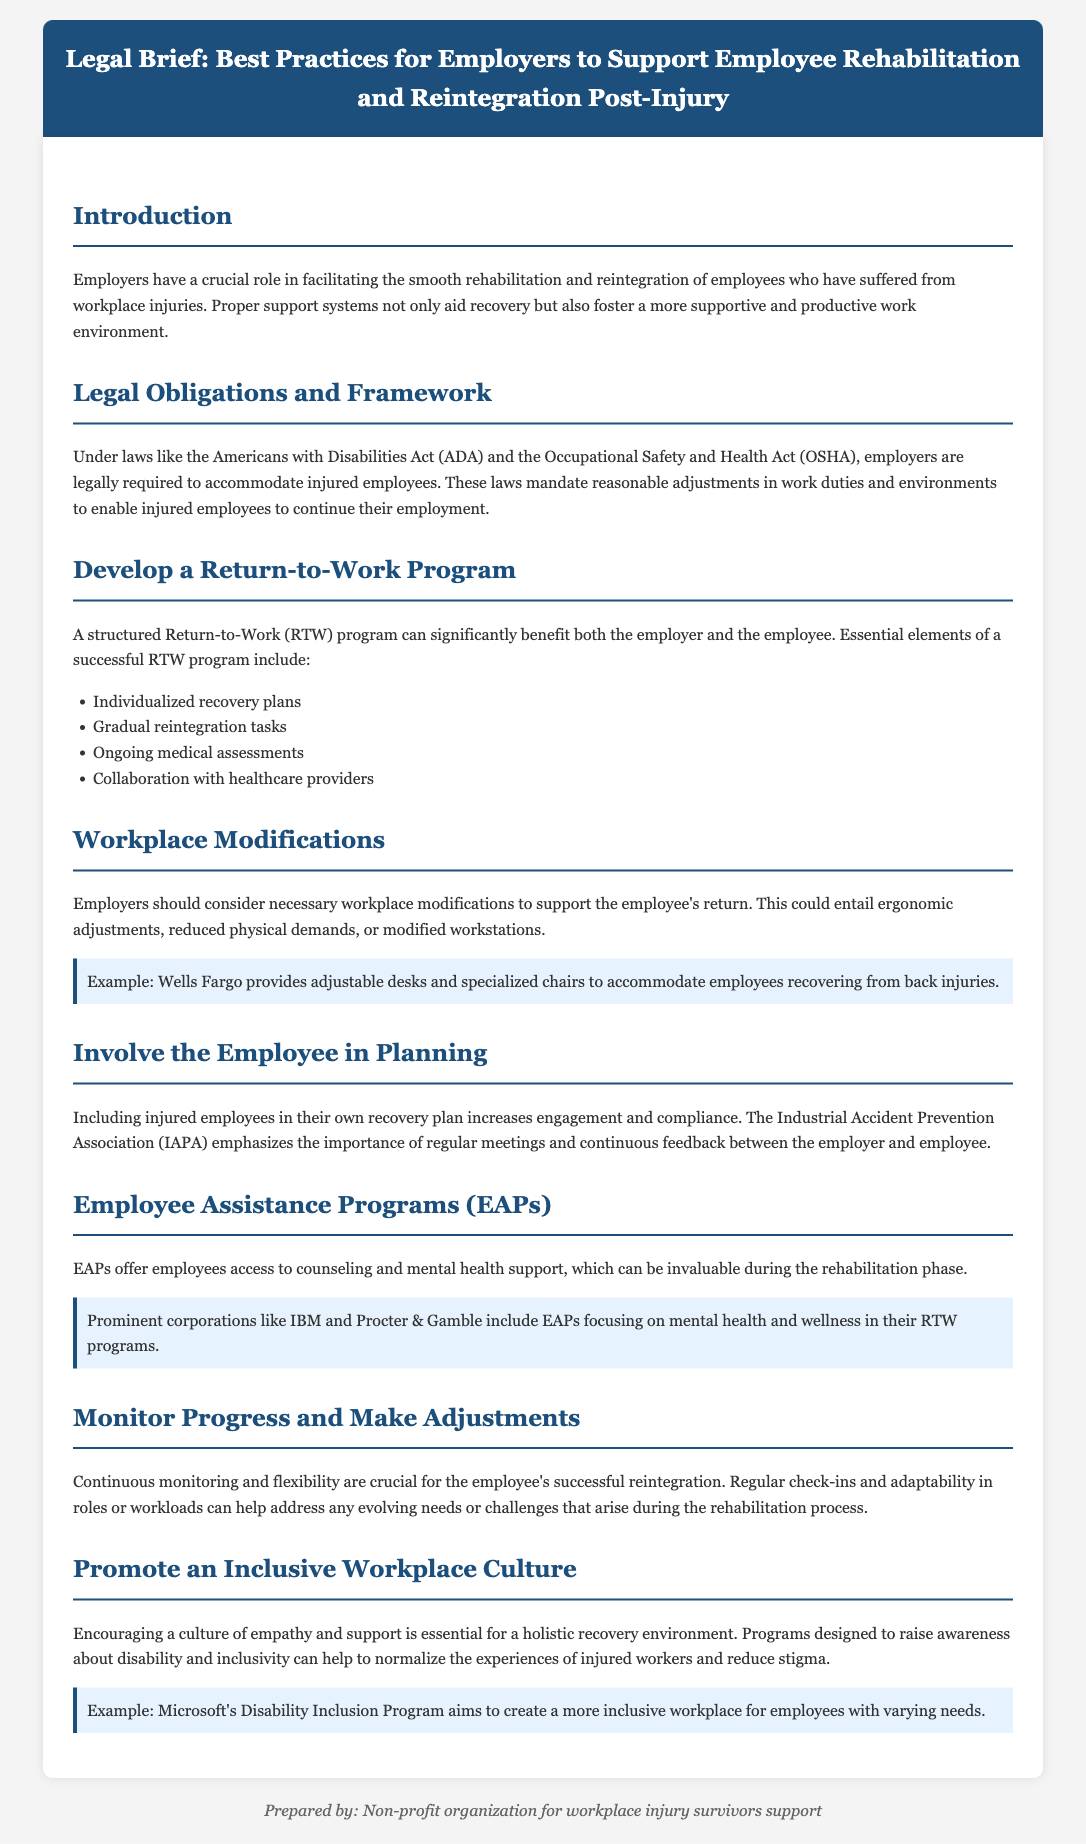what is a structured Return-to-Work program? The document defines a structured Return-to-Work (RTW) program as a way to benefit both the employer and the employee, emphasizing essential elements for its success.
Answer: RTW program which laws require employers to accommodate injured employees? The brief mentions the Americans with Disabilities Act (ADA) and the Occupational Safety and Health Act (OSHA) as the laws that mandate accommodations for injured employees.
Answer: ADA and OSHA what should workplace modifications consider? The document states that necessary workplace modifications should support the employee's return, which could entail ergonomic adjustments, reduced physical demands, or modified workstations.
Answer: ergonomic adjustments who emphasizes the importance of regular meetings between the employer and employee? The Industrial Accident Prevention Association (IAPA) is mentioned as emphasizing the importance of regular meetings and continuous feedback.
Answer: IAPA what type of support do Employee Assistance Programs (EAPs) offer? The document refers to EAPs as offering access to counseling and mental health support, invaluable during the rehabilitation phase.
Answer: counseling and mental health support what does Microsoft's Disability Inclusion Program aim to create? The document highlights that Microsoft's Disability Inclusion Program aims to create a more inclusive workplace for employees with varying needs.
Answer: inclusive workplace how can continuous monitoring help the reintegration process? The brief specifies that continuous monitoring and flexibility are crucial for successful reintegration, meaning regular check-ins and adaptability are necessary.
Answer: regular check-ins and adaptability what role do employers play in employee rehabilitation? Employers are described as having a crucial role in facilitating the smooth rehabilitation and reintegration of employees post-injury.
Answer: facilitating rehabilitation and reintegration 